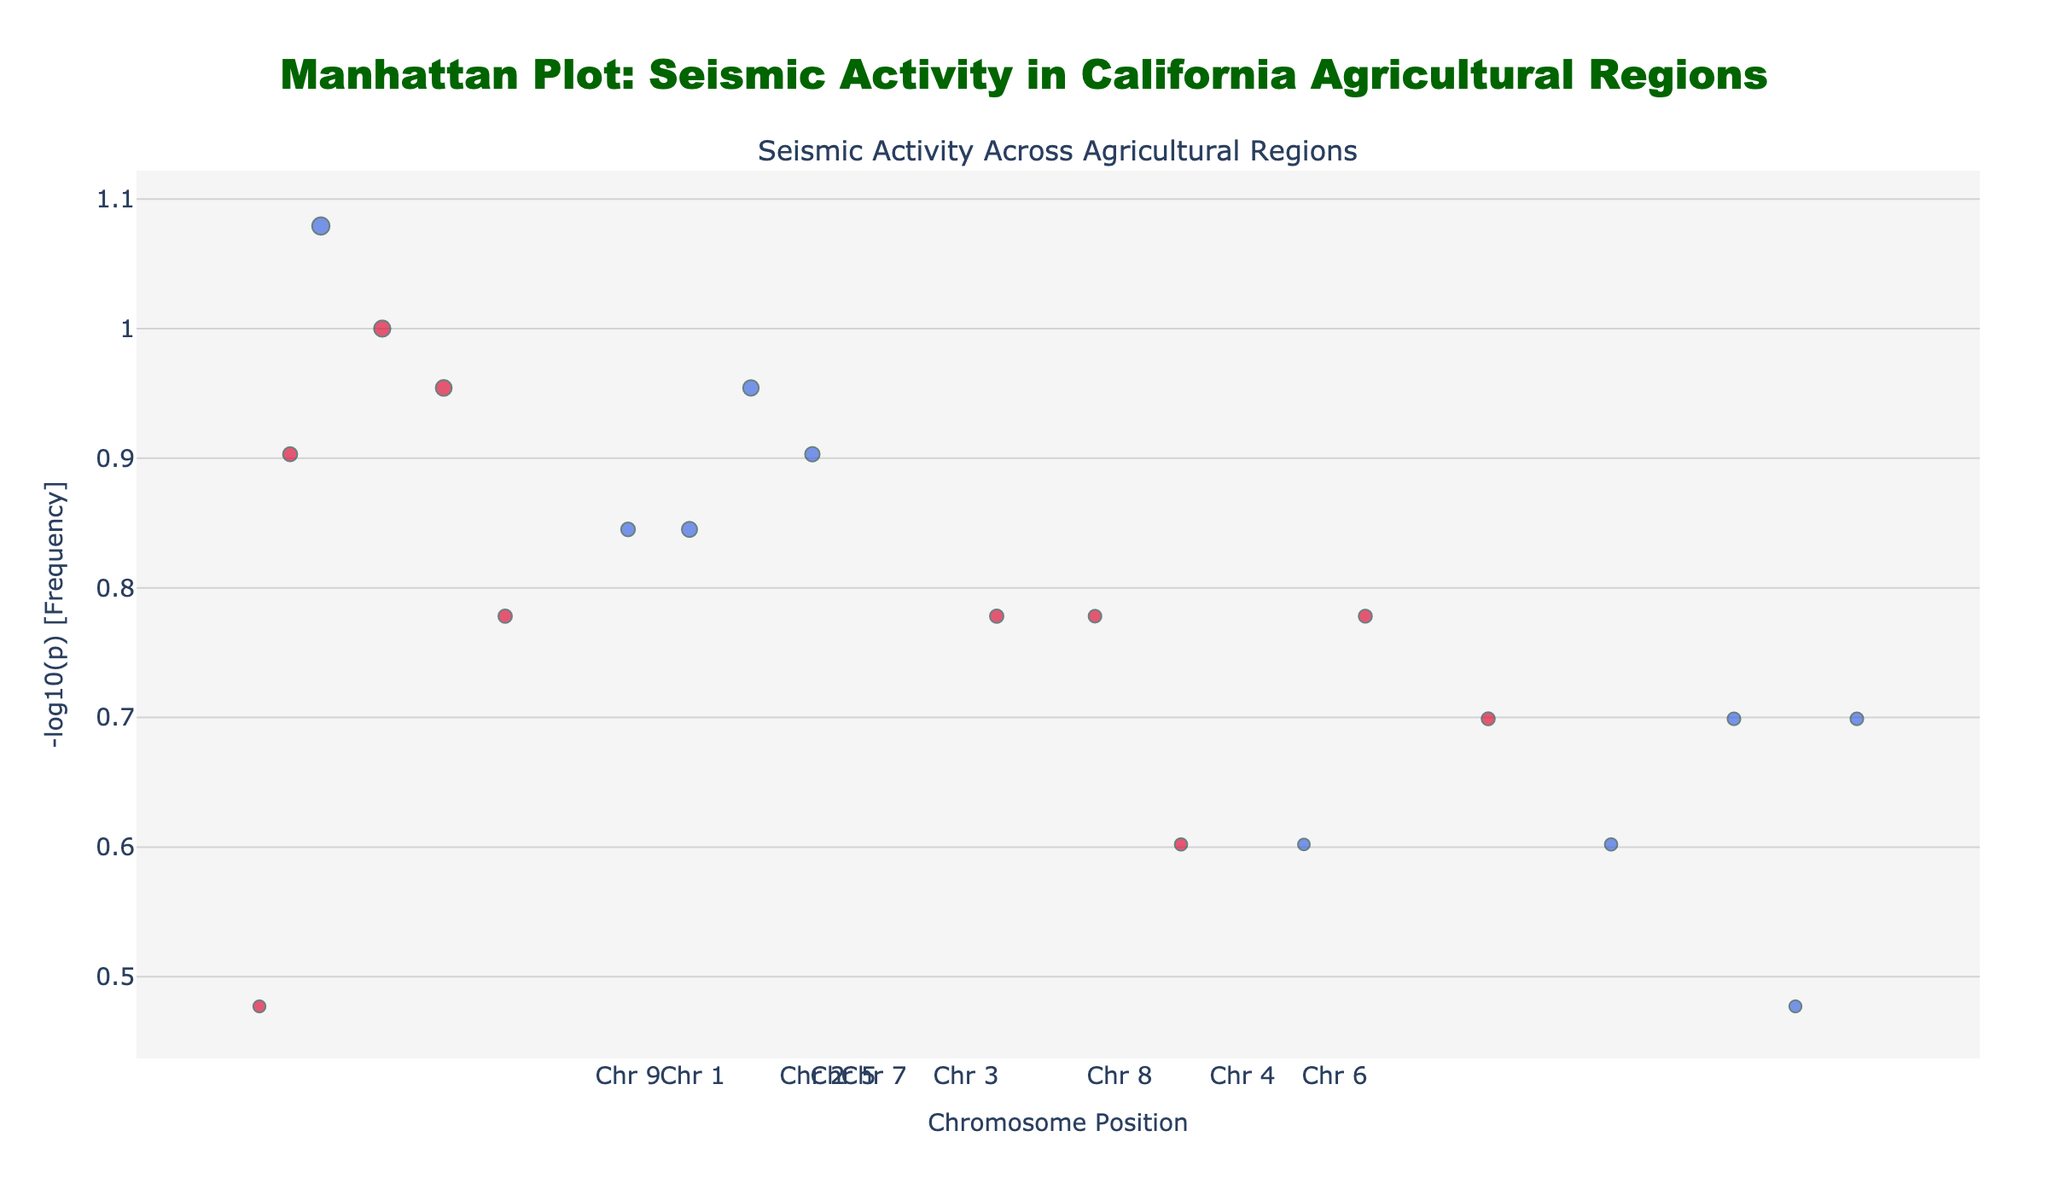What is the title of the plot? The title is usually found at the top of the plot. In this case, it is centered based on the description.
Answer: Manhattan Plot: Seismic Activity in California Agricultural Regions Which region has the highest magnitude seismic activity? The magnitude can be inferred by looking at the size of the markers. The region with the largest marker represents the highest magnitude.
Answer: Imperial Valley Which chromosomes show the highest frequency of seismic activity? Frequency is visualized using the -log10(p) value. The higher the -log10(p), the more frequent the activity. Look for the highest points on the y-axis.
Answer: Chromosomes 2 and 7 Which region has the highest -log10(p) value for seismic activity? The -log10(p) value can be identified based on the height of the markers on the y-axis. Spot the highest point and confirm the region by the hover text or associated marker.
Answer: Imperial Valley How does the seismic activity in the Central Coast compare to the Coachella Valley in terms of frequency? Compare the y-axis values (-log10(p)) of the data points corresponding to the Central Coast and Coachella Valley.
Answer: Central Coast has higher frequency Which chromosome has the highest number of data points? By counting the number of markers (data points) on each chromosome section, determine which has the most.
Answer: Chromosome 7 What is the general trend of seismic magnitude across the regions? Viewing the marker sizes across different chromosomes, look for any patterns in magnitude size.
Answer: Varies without a clear trend How many regions have a seismic magnitude above 4.0? Count the markers whose sizes suggest a magnitude above 4.0. This is typically represented by larger marker sizes.
Answer: 10 Which region shows a seismic activity with a magnitude of 4.8? Find the marker with a size indicative of 4.8 and identify the region through hover text or the marker’s position description.
Answer: Ventura County Is there any region with both high frequency and high magnitude seismic activity? High frequency is indicated by a high -log10(p) value, and high magnitude is shown by large markers. Find if any region appears prominently in both aspects.
Answer: Yes, Imperial Valley 